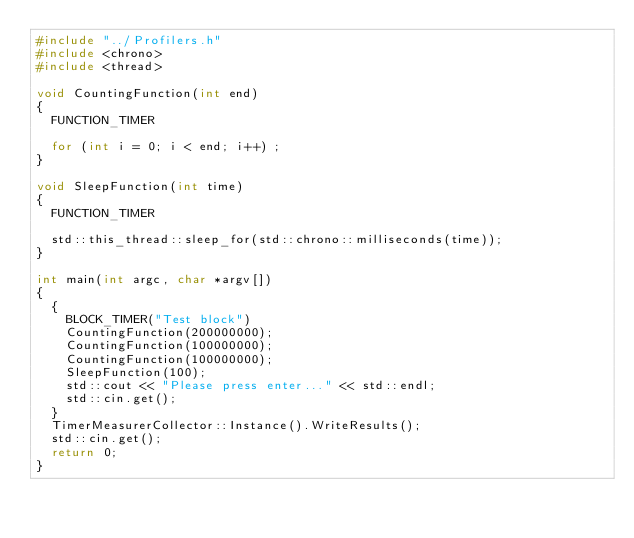Convert code to text. <code><loc_0><loc_0><loc_500><loc_500><_C++_>#include "../Profilers.h"
#include <chrono>
#include <thread>

void CountingFunction(int end)
{
	FUNCTION_TIMER

	for (int i = 0; i < end; i++) ;
}

void SleepFunction(int time)
{
	FUNCTION_TIMER

	std::this_thread::sleep_for(std::chrono::milliseconds(time));
}

int main(int argc, char *argv[])
{
	{
		BLOCK_TIMER("Test block")
		CountingFunction(200000000);
		CountingFunction(100000000);
		CountingFunction(100000000);
		SleepFunction(100);
		std::cout << "Please press enter..." << std::endl;
		std::cin.get();
	}
	TimerMeasurerCollector::Instance().WriteResults();
	std::cin.get();
	return 0;
}

</code> 